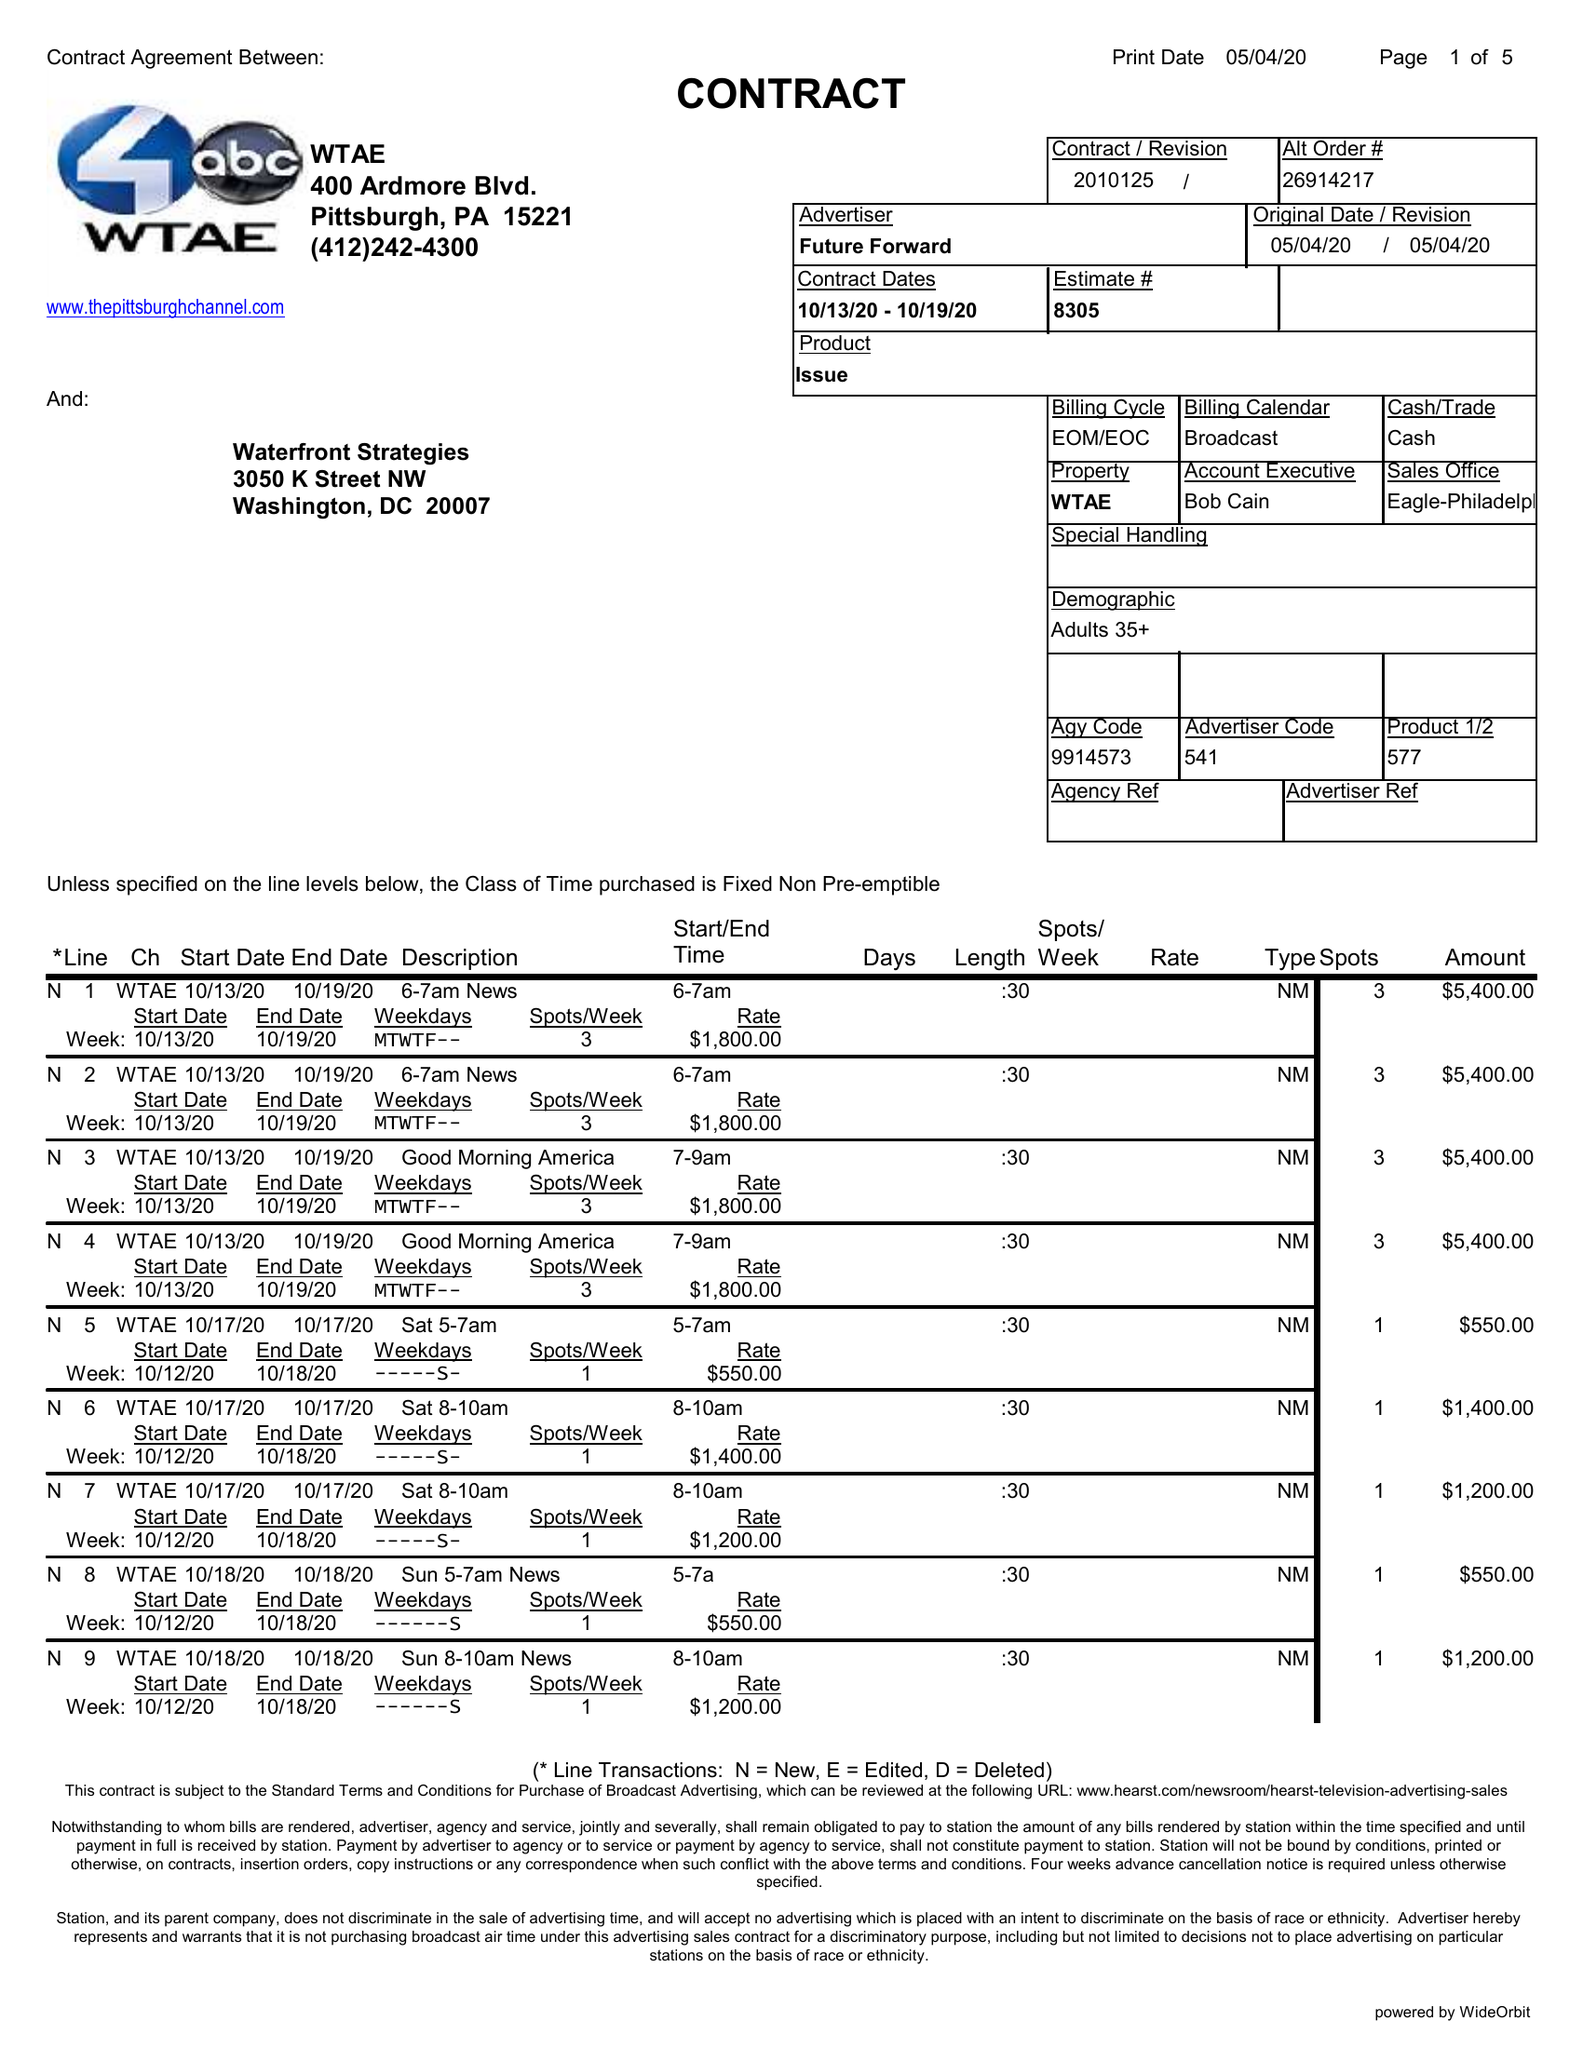What is the value for the flight_from?
Answer the question using a single word or phrase. 10/13/20 